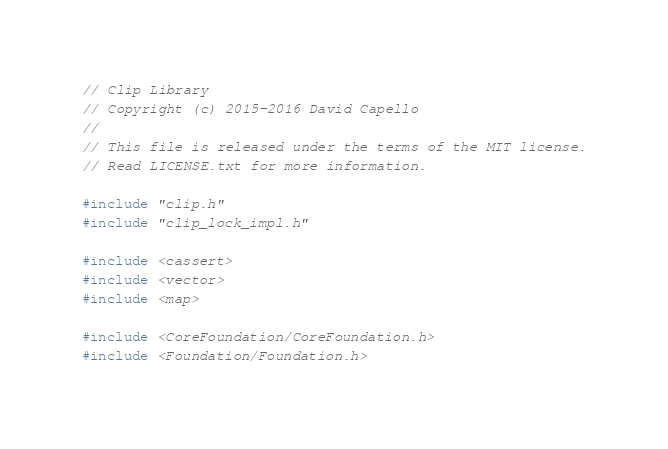<code> <loc_0><loc_0><loc_500><loc_500><_ObjectiveC_>// Clip Library
// Copyright (c) 2015-2016 David Capello
//
// This file is released under the terms of the MIT license.
// Read LICENSE.txt for more information.

#include "clip.h"
#include "clip_lock_impl.h"

#include <cassert>
#include <vector>
#include <map>

#include <CoreFoundation/CoreFoundation.h>
#include <Foundation/Foundation.h></code> 